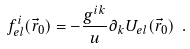<formula> <loc_0><loc_0><loc_500><loc_500>f _ { e l } ^ { i } ( \vec { r } _ { 0 } ) = - \frac { g ^ { i k } } { u } \partial _ { k } U _ { e l } ( \vec { r } _ { 0 } ) \ .</formula> 